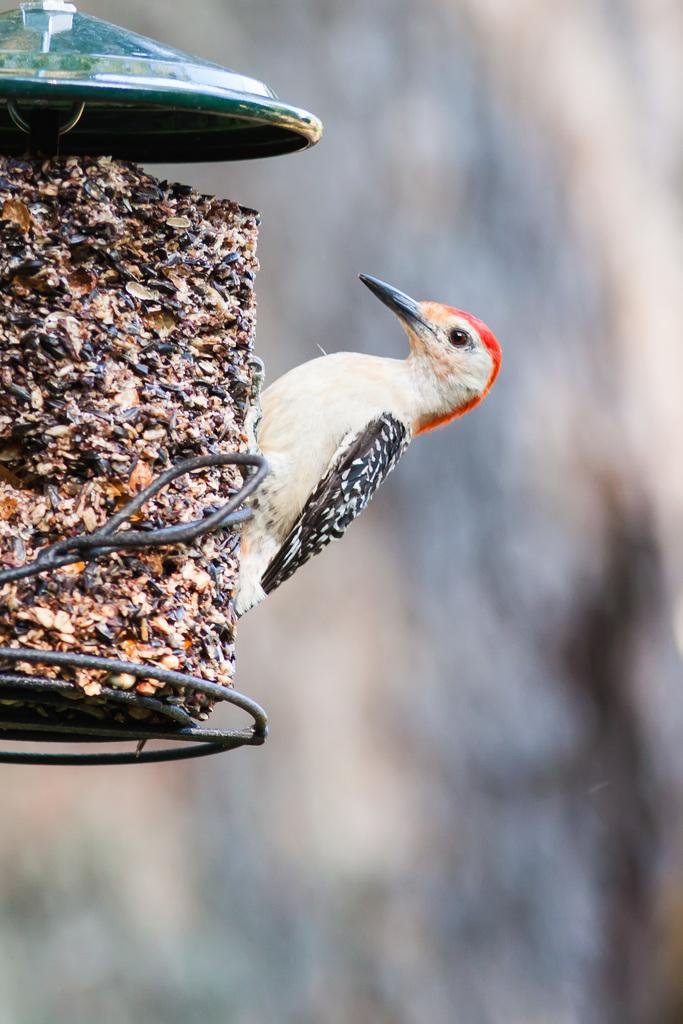What type of animal is present in the image? There is a bird in the image. Where is the bird located in the image? The bird is on an object that resembles a stand. Can you describe the background of the image? The background of the image is blurry. What channel is the bird watching in the image? There is no television or channel present in the image; it features a bird on a stand with a blurry background. 